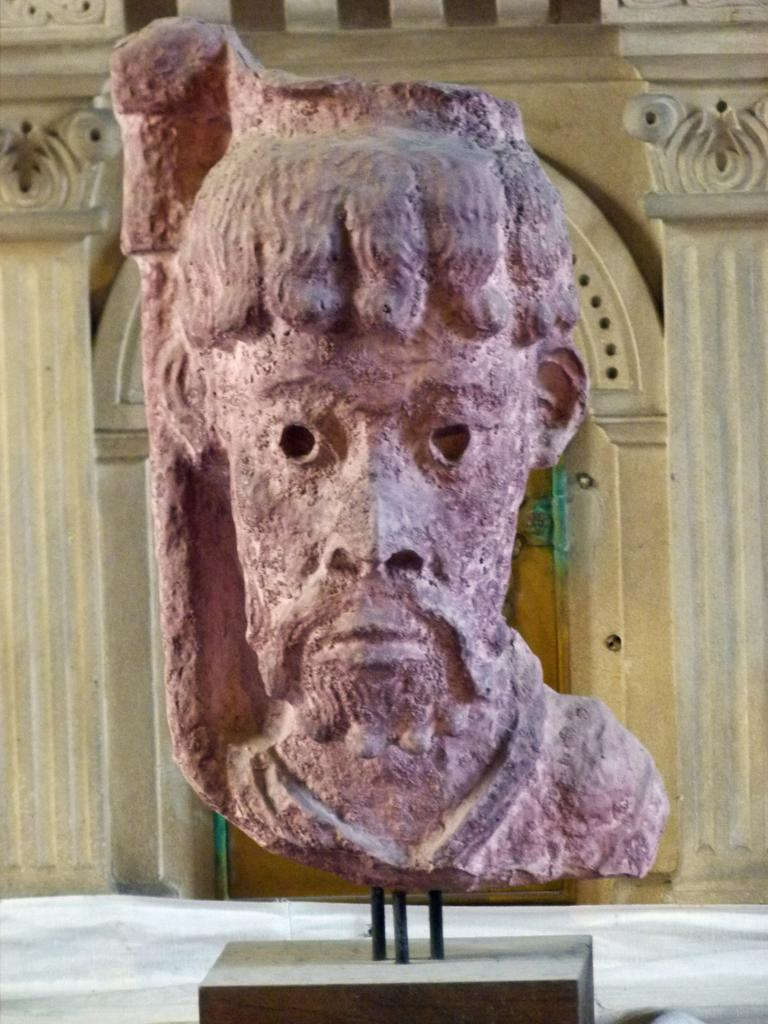What is the main subject in the image? There is a statue in the image. What can be seen behind the statue? There are two pillars behind the statue. What architectural feature is present between the pillars? There is an arch between the pillars. What is located under the arch? There is a door under the arch. What type of fork can be seen in the hands of the statue? There is no fork present in the image; the statue does not have any objects in its hands. 